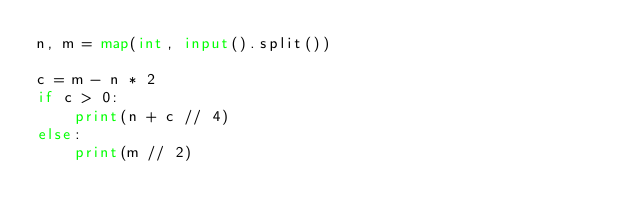<code> <loc_0><loc_0><loc_500><loc_500><_Python_>n, m = map(int, input().split())

c = m - n * 2
if c > 0:
    print(n + c // 4)
else:
    print(m // 2)</code> 